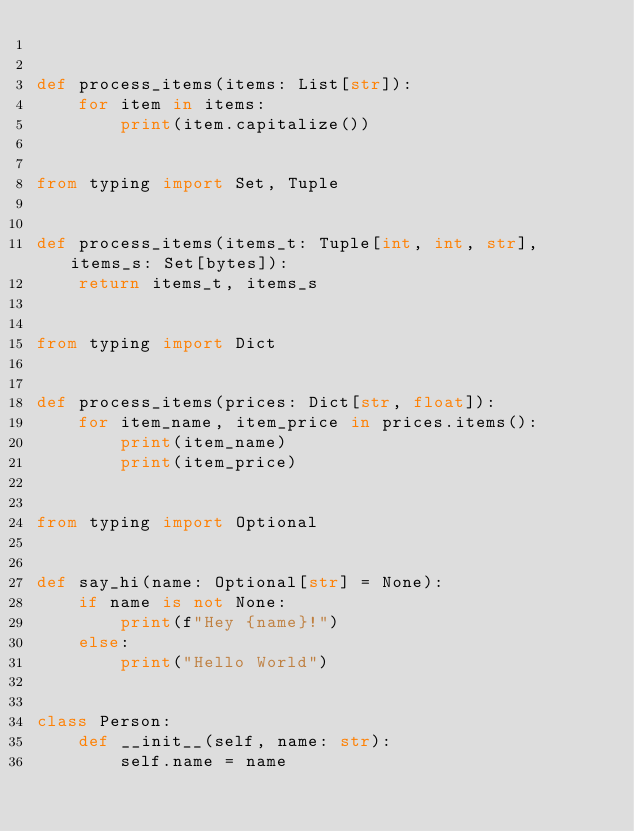<code> <loc_0><loc_0><loc_500><loc_500><_Python_>

def process_items(items: List[str]):
    for item in items:
        print(item.capitalize())


from typing import Set, Tuple


def process_items(items_t: Tuple[int, int, str], items_s: Set[bytes]):
    return items_t, items_s


from typing import Dict


def process_items(prices: Dict[str, float]):
    for item_name, item_price in prices.items():
        print(item_name)
        print(item_price)


from typing import Optional


def say_hi(name: Optional[str] = None):
    if name is not None:
        print(f"Hey {name}!")
    else:
        print("Hello World")


class Person:
    def __init__(self, name: str):
        self.name = name

</code> 